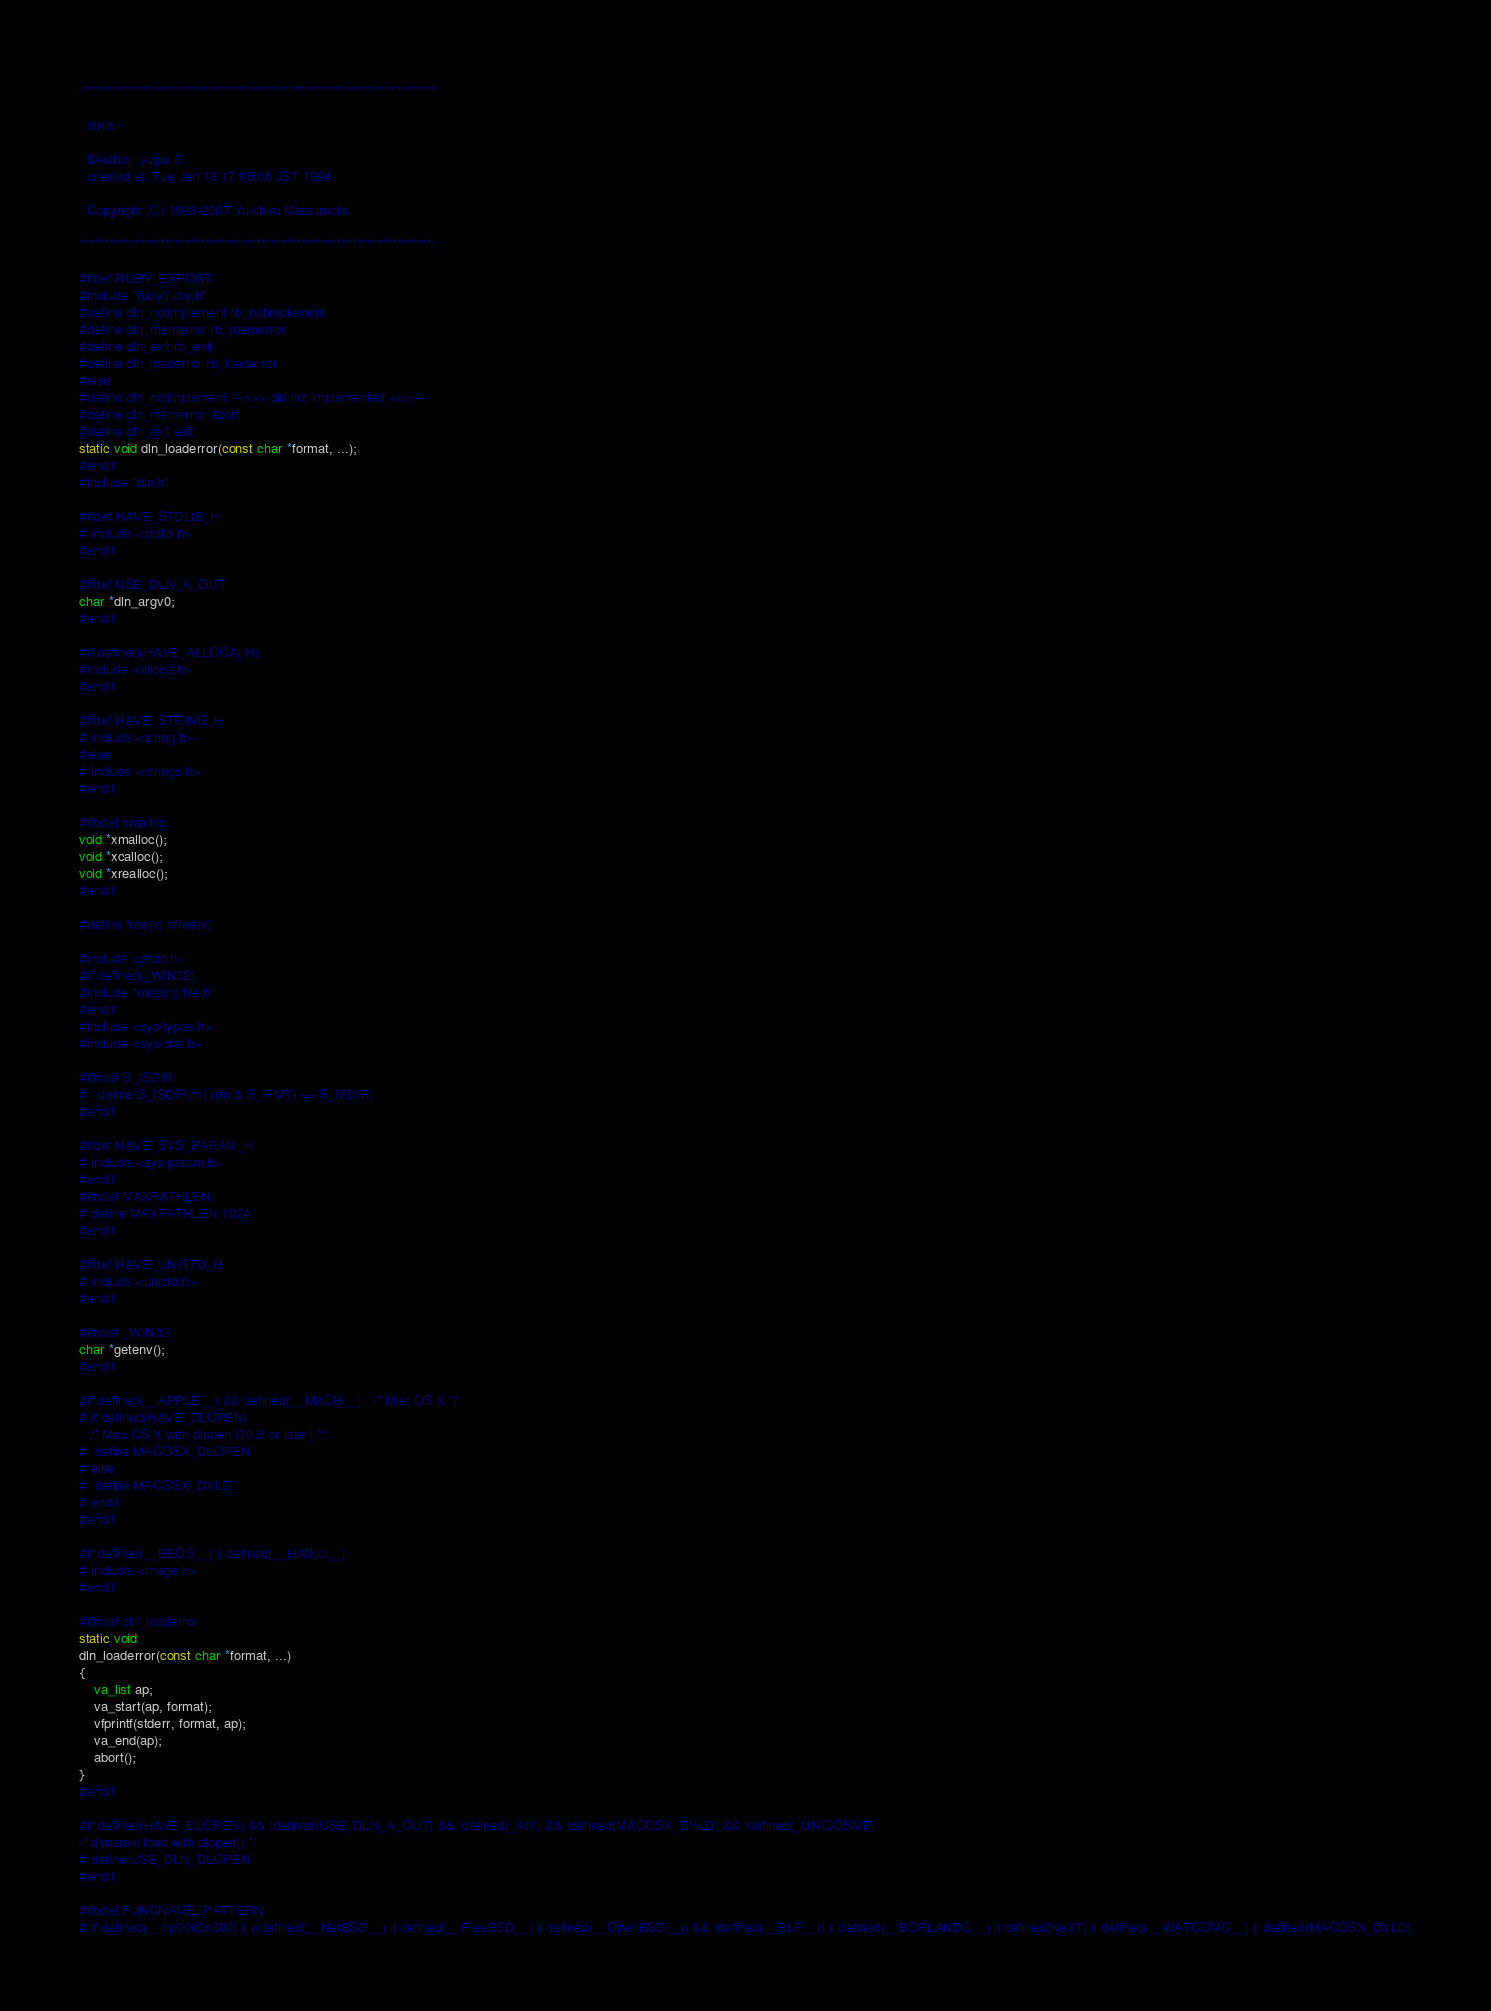Convert code to text. <code><loc_0><loc_0><loc_500><loc_500><_C_>/**********************************************************************

  dln.c -

  $Author: yugui $
  created at: Tue Jan 18 17:05:06 JST 1994

  Copyright (C) 1993-2007 Yukihiro Matsumoto

**********************************************************************/

#ifdef RUBY_EXPORT
#include "ruby/ruby.h"
#define dln_notimplement rb_notimplement
#define dln_memerror rb_memerror
#define dln_exit rb_exit
#define dln_loaderror rb_loaderror
#else
#define dln_notimplement --->>> dln not implemented <<<---
#define dln_memerror abort
#define dln_exit exit
static void dln_loaderror(const char *format, ...);
#endif
#include "dln.h"

#ifdef HAVE_STDLIB_H
# include <stdlib.h>
#endif

#ifdef USE_DLN_A_OUT
char *dln_argv0;
#endif

#if defined(HAVE_ALLOCA_H)
#include <alloca.h>
#endif

#ifdef HAVE_STRING_H
# include <string.h>
#else
# include <strings.h>
#endif

#ifndef xmalloc
void *xmalloc();
void *xcalloc();
void *xrealloc();
#endif

#define free(x) xfree(x)

#include <stdio.h>
#if defined(_WIN32)
#include "missing/file.h"
#endif
#include <sys/types.h>
#include <sys/stat.h>

#ifndef S_ISDIR
#   define S_ISDIR(m) ((m & S_IFMT) == S_IFDIR)
#endif

#ifdef HAVE_SYS_PARAM_H
# include <sys/param.h>
#endif
#ifndef MAXPATHLEN
# define MAXPATHLEN 1024
#endif

#ifdef HAVE_UNISTD_H
# include <unistd.h>
#endif

#ifndef _WIN32
char *getenv();
#endif

#if defined(__APPLE__) && defined(__MACH__)   /* Mac OS X */
# if defined(HAVE_DLOPEN)
   /* Mac OS X with dlopen (10.3 or later) */
#  define MACOSX_DLOPEN
# else
#  define MACOSX_DYLD
# endif
#endif

#if defined(__BEOS__) || defined(__HAIKU__)
# include <image.h>
#endif

#ifndef dln_loaderror
static void
dln_loaderror(const char *format, ...)
{
    va_list ap;
    va_start(ap, format);
    vfprintf(stderr, format, ap);
    va_end(ap);
    abort();
}
#endif

#if defined(HAVE_DLOPEN) && !defined(USE_DLN_A_OUT) && !defined(_AIX) && !defined(MACOSX_DYLD) && !defined(_UNICOSMP)
/* dynamic load with dlopen() */
# define USE_DLN_DLOPEN
#endif

#ifndef FUNCNAME_PATTERN
# if defined(__hp9000s300) || ((defined(__NetBSD__) || defined(__FreeBSD__) || defined(__OpenBSD__)) && !defined(__ELF__)) || defined(__BORLANDC__) || defined(NeXT) || defined(__WATCOMC__) || defined(MACOSX_DYLD)</code> 